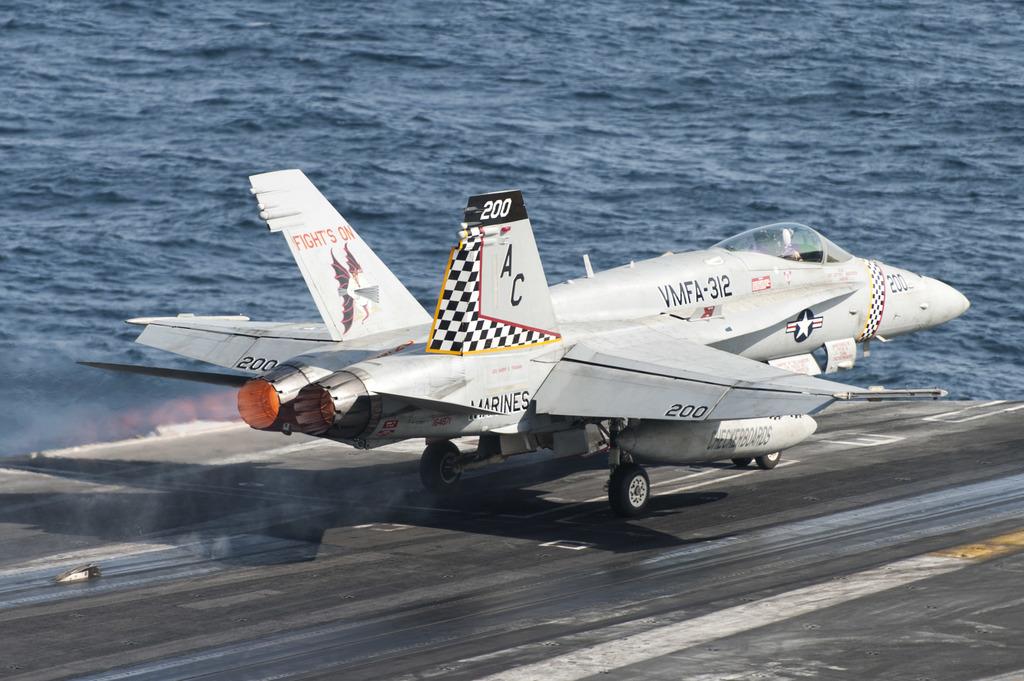What number is on the wings of this jet?
Your response must be concise. 200. What are the letters on the side of the jet?
Offer a very short reply. Ac. 